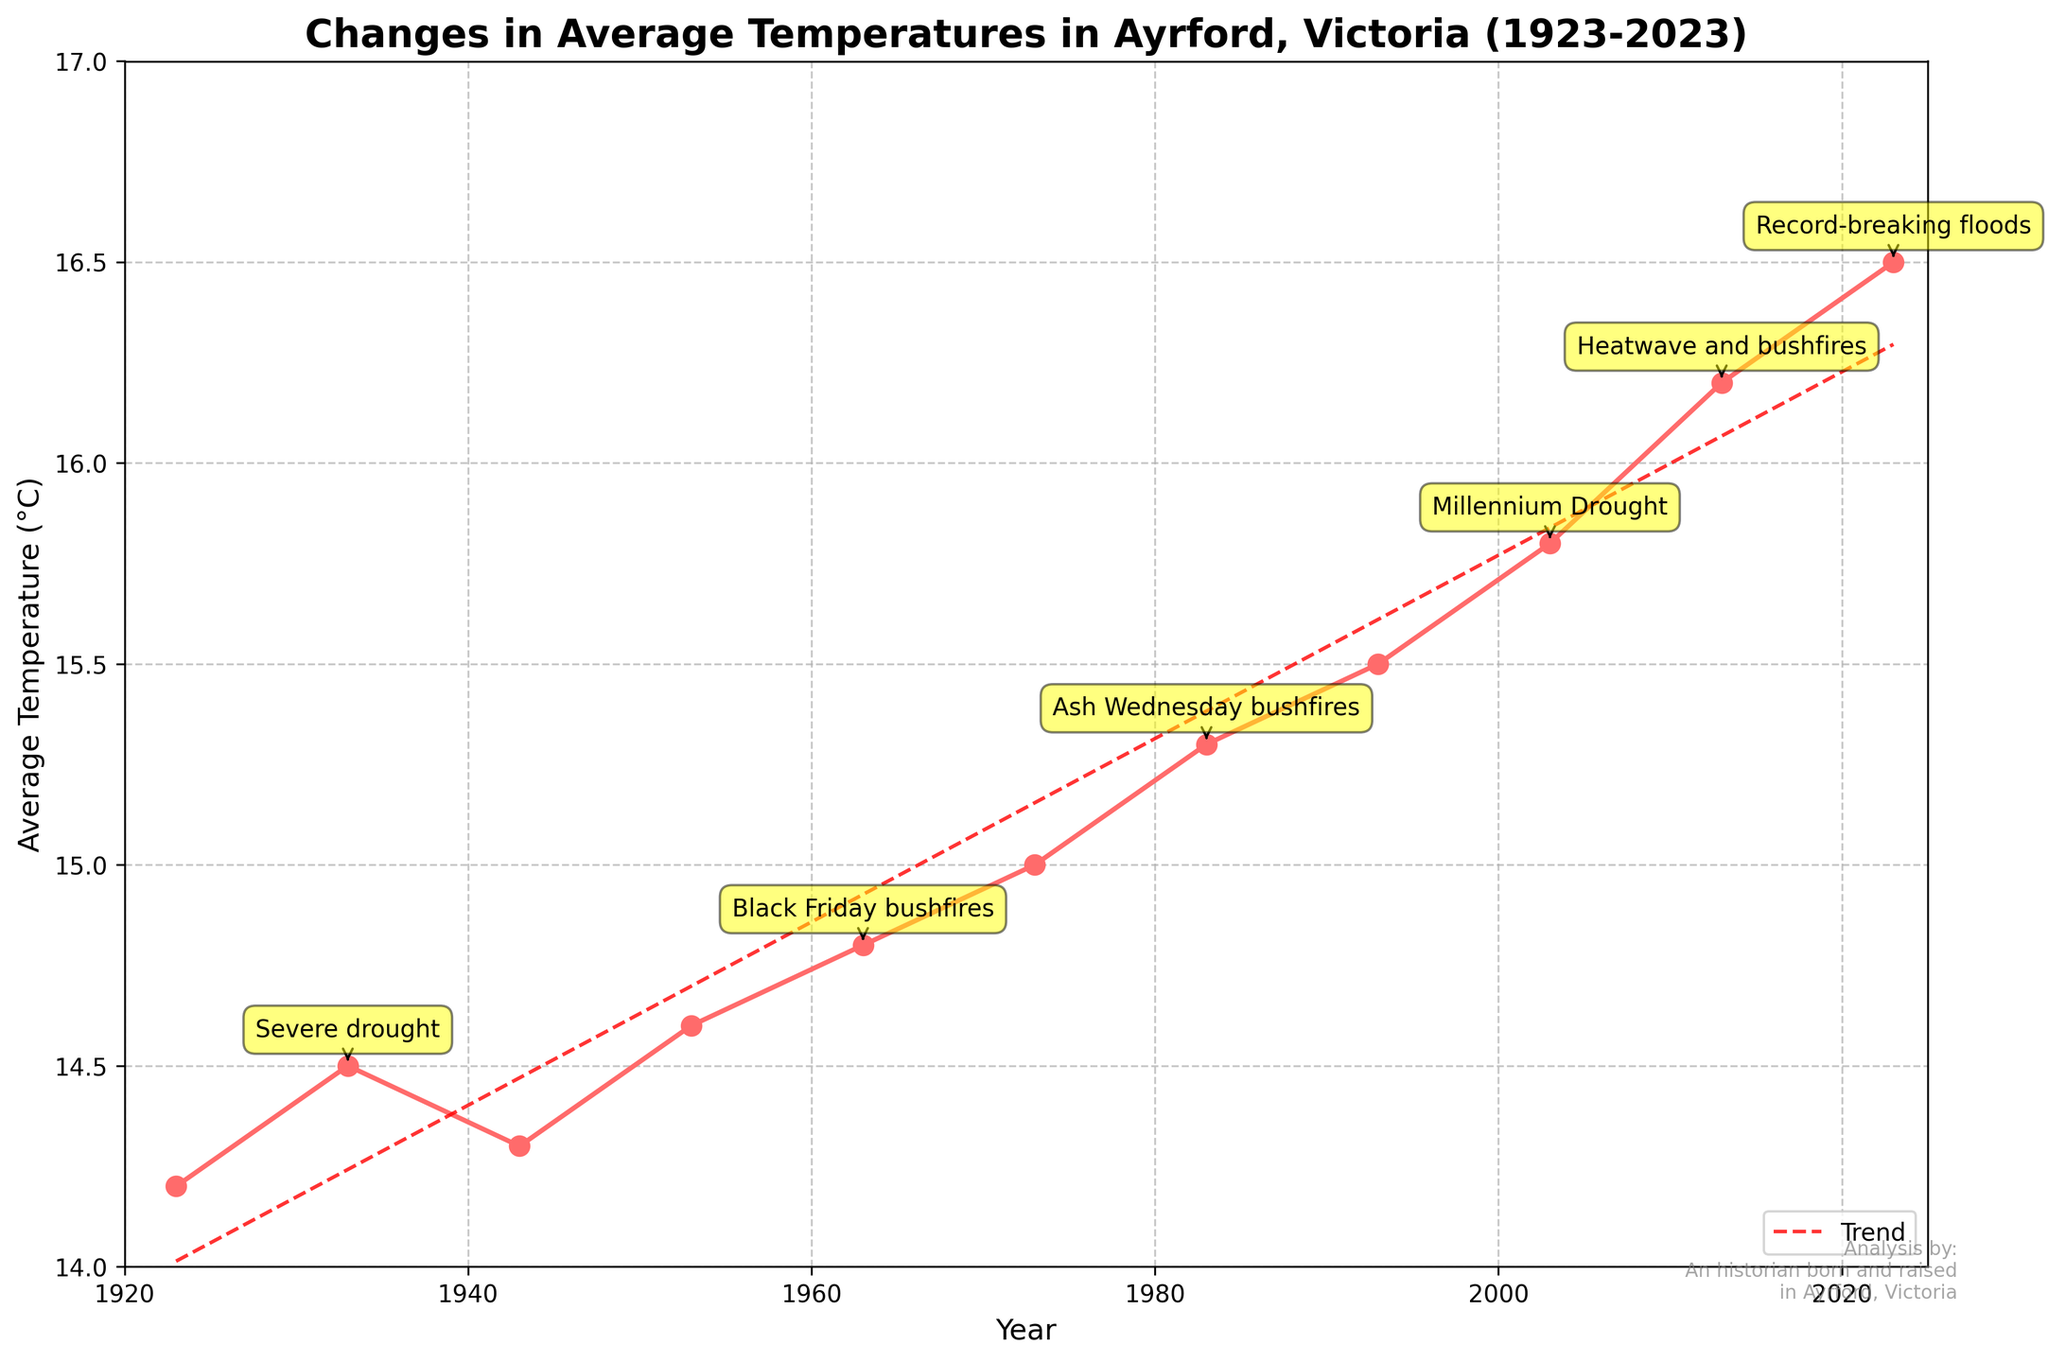What is the general trend in average temperatures over the past 100 years in Ayrford, Victoria? To determine the trend, look at the direction of the plotted line from the beginning (1923) to the end (2023) and also consider the trend line shown in red dashed. Both indicate an overall increase.
Answer: Increasing What were the average temperatures during the years with notable extreme weather events? Identify the years with extreme weather events from the annotations and then check the corresponding temperatures on the y-axis. These years and their corresponding temperatures are 1933 (14.5°C), 1963 (14.8°C), 1983 (15.3°C), 2003 (15.8°C), 2013 (16.2°C), and 2023 (16.5°C).
Answer: 14.5°C, 14.8°C, 15.3°C, 15.8°C, 16.2°C, 16.5°C Which year experienced the highest average temperature? Look at the highest point on the y-axis and find the corresponding year on the x-axis. The highest point corresponds to the year 2023 with an average temperature of 16.5°C.
Answer: 2023 How much did the average temperature change between 1923 and 2023? Subtract the average temperature in 1923 (14.2°C) from the average temperature in 2023 (16.5°C). This results in a change of 2.3°C.
Answer: 2.3°C What visual cues are used to highlight extreme weather events on the graph? Extreme weather events are annotated with text boxes that are highlighted in yellow and have arrows pointing to the corresponding data points on the line plot.
Answer: Yellow text boxes, arrows Which period had a greater increase in average temperature: from 1923 to 1963, or from 1983 to 2023? Calculate the temperature change from 1923 to 1963 (14.2°C to 14.8°C) which is 0.6°C, and from 1983 to 2023 (15.3°C to 16.5°C) which is 1.2°C. Compare these differences to see that the increase from 1983 to 2023 is greater.
Answer: 1983 to 2023 What is the average temperature for the years listed with extreme weather events? Identify the temperatures for years with extreme weather events: 14.5°C (1933), 14.8°C (1963), 15.3°C (1983), 15.8°C (2003), 16.2°C (2013), and 16.5°C (2023). Sum these temperatures (14.5 + 14.8 + 15.3 + 15.8 + 16.2 + 16.5 = 93.1°C) and divide by 6 to find the average: 15.52°C.
Answer: 15.52°C Did the Millennium Drought coincide with an increase or decrease in the average temperature? Look at the year 2003 when the Millennium Drought is annotated. The average temperature is 15.8°C, which is higher than the previous recorded temperature in 1993 (15.5°C). It coincides with an increase.
Answer: Increase How many extreme weather events are annotated on the graph? Count the number of yellow text box annotations on the graph. There are six annotations for extreme weather events.
Answer: Six What was the temperature difference between the year of Black Friday bushfires and Ash Wednesday bushfires? The average temperature for the year 1963 (Black Friday bushfires) is 14.8°C, and for the year 1983 (Ash Wednesday bushfires) is 15.3°C. Subtract these temperatures to find the difference, which is 15.3°C - 14.8°C = 0.5°C.
Answer: 0.5°C 